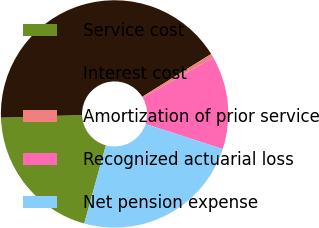Convert chart. <chart><loc_0><loc_0><loc_500><loc_500><pie_chart><fcel>Service cost<fcel>Interest cost<fcel>Amortization of prior service<fcel>Recognized actuarial loss<fcel>Net pension expense<nl><fcel>20.18%<fcel>41.68%<fcel>0.57%<fcel>13.27%<fcel>24.3%<nl></chart> 